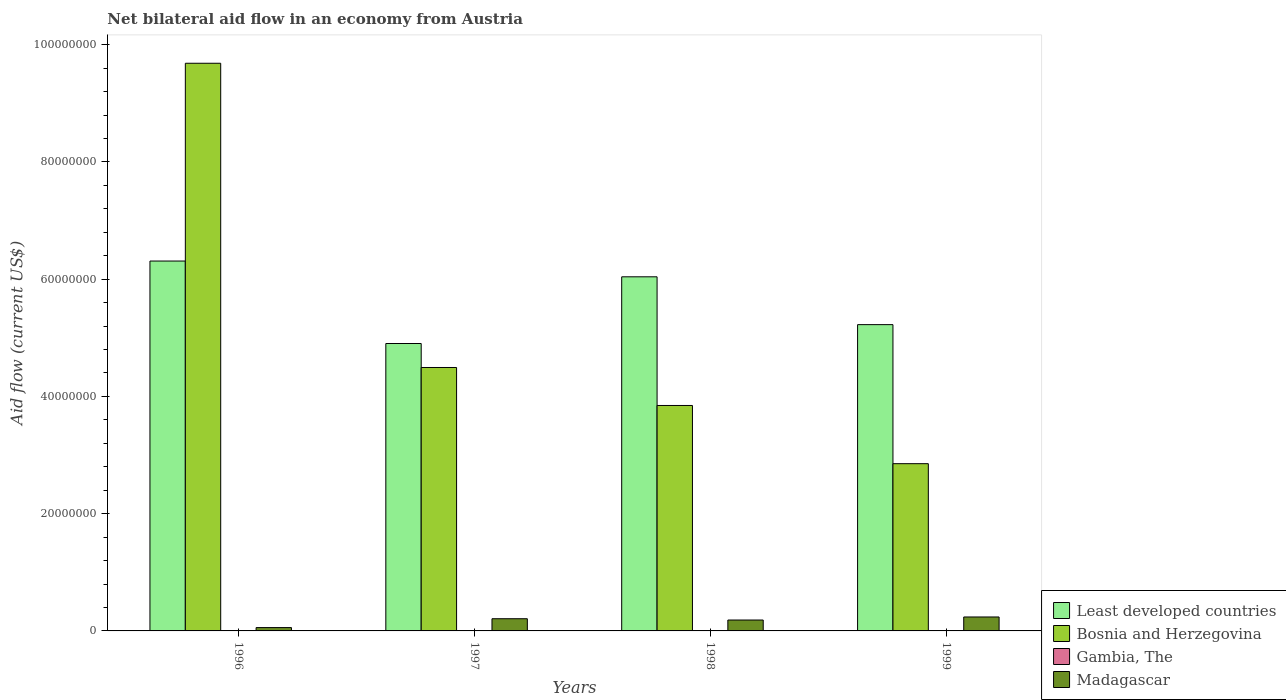Are the number of bars per tick equal to the number of legend labels?
Give a very brief answer. No. Are the number of bars on each tick of the X-axis equal?
Make the answer very short. No. How many bars are there on the 4th tick from the left?
Keep it short and to the point. 4. How many bars are there on the 2nd tick from the right?
Your response must be concise. 4. What is the net bilateral aid flow in Gambia, The in 1999?
Provide a succinct answer. 7.00e+04. Across all years, what is the maximum net bilateral aid flow in Madagascar?
Make the answer very short. 2.38e+06. Across all years, what is the minimum net bilateral aid flow in Madagascar?
Make the answer very short. 5.70e+05. In which year was the net bilateral aid flow in Least developed countries maximum?
Offer a terse response. 1996. What is the total net bilateral aid flow in Least developed countries in the graph?
Make the answer very short. 2.25e+08. What is the difference between the net bilateral aid flow in Gambia, The in 1998 and that in 1999?
Offer a terse response. -6.00e+04. What is the difference between the net bilateral aid flow in Madagascar in 1997 and the net bilateral aid flow in Gambia, The in 1996?
Offer a terse response. 2.05e+06. What is the average net bilateral aid flow in Gambia, The per year?
Give a very brief answer. 2.75e+04. In the year 1998, what is the difference between the net bilateral aid flow in Least developed countries and net bilateral aid flow in Madagascar?
Your answer should be compact. 5.86e+07. What is the ratio of the net bilateral aid flow in Bosnia and Herzegovina in 1997 to that in 1999?
Make the answer very short. 1.58. Is the net bilateral aid flow in Bosnia and Herzegovina in 1996 less than that in 1999?
Your response must be concise. No. What is the difference between the highest and the second highest net bilateral aid flow in Bosnia and Herzegovina?
Offer a terse response. 5.19e+07. What is the difference between the highest and the lowest net bilateral aid flow in Bosnia and Herzegovina?
Your answer should be very brief. 6.83e+07. Are all the bars in the graph horizontal?
Give a very brief answer. No. How many years are there in the graph?
Your answer should be very brief. 4. Are the values on the major ticks of Y-axis written in scientific E-notation?
Give a very brief answer. No. Does the graph contain grids?
Keep it short and to the point. No. Where does the legend appear in the graph?
Offer a terse response. Bottom right. How are the legend labels stacked?
Your response must be concise. Vertical. What is the title of the graph?
Provide a short and direct response. Net bilateral aid flow in an economy from Austria. What is the label or title of the X-axis?
Your answer should be very brief. Years. What is the label or title of the Y-axis?
Give a very brief answer. Aid flow (current US$). What is the Aid flow (current US$) in Least developed countries in 1996?
Make the answer very short. 6.31e+07. What is the Aid flow (current US$) of Bosnia and Herzegovina in 1996?
Provide a short and direct response. 9.68e+07. What is the Aid flow (current US$) of Madagascar in 1996?
Provide a succinct answer. 5.70e+05. What is the Aid flow (current US$) in Least developed countries in 1997?
Provide a short and direct response. 4.90e+07. What is the Aid flow (current US$) in Bosnia and Herzegovina in 1997?
Ensure brevity in your answer.  4.49e+07. What is the Aid flow (current US$) of Gambia, The in 1997?
Offer a terse response. 0. What is the Aid flow (current US$) of Madagascar in 1997?
Your response must be concise. 2.08e+06. What is the Aid flow (current US$) of Least developed countries in 1998?
Provide a succinct answer. 6.04e+07. What is the Aid flow (current US$) in Bosnia and Herzegovina in 1998?
Make the answer very short. 3.85e+07. What is the Aid flow (current US$) in Gambia, The in 1998?
Your response must be concise. 10000. What is the Aid flow (current US$) of Madagascar in 1998?
Offer a very short reply. 1.86e+06. What is the Aid flow (current US$) of Least developed countries in 1999?
Keep it short and to the point. 5.22e+07. What is the Aid flow (current US$) of Bosnia and Herzegovina in 1999?
Your response must be concise. 2.85e+07. What is the Aid flow (current US$) of Madagascar in 1999?
Provide a short and direct response. 2.38e+06. Across all years, what is the maximum Aid flow (current US$) in Least developed countries?
Provide a short and direct response. 6.31e+07. Across all years, what is the maximum Aid flow (current US$) of Bosnia and Herzegovina?
Provide a succinct answer. 9.68e+07. Across all years, what is the maximum Aid flow (current US$) in Gambia, The?
Provide a short and direct response. 7.00e+04. Across all years, what is the maximum Aid flow (current US$) of Madagascar?
Ensure brevity in your answer.  2.38e+06. Across all years, what is the minimum Aid flow (current US$) of Least developed countries?
Give a very brief answer. 4.90e+07. Across all years, what is the minimum Aid flow (current US$) in Bosnia and Herzegovina?
Your response must be concise. 2.85e+07. Across all years, what is the minimum Aid flow (current US$) in Madagascar?
Provide a short and direct response. 5.70e+05. What is the total Aid flow (current US$) of Least developed countries in the graph?
Offer a terse response. 2.25e+08. What is the total Aid flow (current US$) of Bosnia and Herzegovina in the graph?
Provide a succinct answer. 2.09e+08. What is the total Aid flow (current US$) of Madagascar in the graph?
Keep it short and to the point. 6.89e+06. What is the difference between the Aid flow (current US$) of Least developed countries in 1996 and that in 1997?
Provide a succinct answer. 1.41e+07. What is the difference between the Aid flow (current US$) in Bosnia and Herzegovina in 1996 and that in 1997?
Your answer should be compact. 5.19e+07. What is the difference between the Aid flow (current US$) in Madagascar in 1996 and that in 1997?
Your answer should be very brief. -1.51e+06. What is the difference between the Aid flow (current US$) in Least developed countries in 1996 and that in 1998?
Give a very brief answer. 2.69e+06. What is the difference between the Aid flow (current US$) of Bosnia and Herzegovina in 1996 and that in 1998?
Keep it short and to the point. 5.84e+07. What is the difference between the Aid flow (current US$) of Gambia, The in 1996 and that in 1998?
Your answer should be compact. 2.00e+04. What is the difference between the Aid flow (current US$) of Madagascar in 1996 and that in 1998?
Provide a succinct answer. -1.29e+06. What is the difference between the Aid flow (current US$) of Least developed countries in 1996 and that in 1999?
Ensure brevity in your answer.  1.08e+07. What is the difference between the Aid flow (current US$) in Bosnia and Herzegovina in 1996 and that in 1999?
Ensure brevity in your answer.  6.83e+07. What is the difference between the Aid flow (current US$) in Madagascar in 1996 and that in 1999?
Your response must be concise. -1.81e+06. What is the difference between the Aid flow (current US$) of Least developed countries in 1997 and that in 1998?
Provide a short and direct response. -1.14e+07. What is the difference between the Aid flow (current US$) in Bosnia and Herzegovina in 1997 and that in 1998?
Offer a very short reply. 6.48e+06. What is the difference between the Aid flow (current US$) of Madagascar in 1997 and that in 1998?
Give a very brief answer. 2.20e+05. What is the difference between the Aid flow (current US$) of Least developed countries in 1997 and that in 1999?
Make the answer very short. -3.22e+06. What is the difference between the Aid flow (current US$) of Bosnia and Herzegovina in 1997 and that in 1999?
Provide a short and direct response. 1.64e+07. What is the difference between the Aid flow (current US$) of Madagascar in 1997 and that in 1999?
Offer a terse response. -3.00e+05. What is the difference between the Aid flow (current US$) in Least developed countries in 1998 and that in 1999?
Provide a succinct answer. 8.16e+06. What is the difference between the Aid flow (current US$) in Bosnia and Herzegovina in 1998 and that in 1999?
Keep it short and to the point. 9.93e+06. What is the difference between the Aid flow (current US$) in Gambia, The in 1998 and that in 1999?
Your answer should be compact. -6.00e+04. What is the difference between the Aid flow (current US$) of Madagascar in 1998 and that in 1999?
Keep it short and to the point. -5.20e+05. What is the difference between the Aid flow (current US$) in Least developed countries in 1996 and the Aid flow (current US$) in Bosnia and Herzegovina in 1997?
Ensure brevity in your answer.  1.82e+07. What is the difference between the Aid flow (current US$) of Least developed countries in 1996 and the Aid flow (current US$) of Madagascar in 1997?
Your answer should be very brief. 6.10e+07. What is the difference between the Aid flow (current US$) in Bosnia and Herzegovina in 1996 and the Aid flow (current US$) in Madagascar in 1997?
Your answer should be compact. 9.48e+07. What is the difference between the Aid flow (current US$) in Gambia, The in 1996 and the Aid flow (current US$) in Madagascar in 1997?
Give a very brief answer. -2.05e+06. What is the difference between the Aid flow (current US$) in Least developed countries in 1996 and the Aid flow (current US$) in Bosnia and Herzegovina in 1998?
Ensure brevity in your answer.  2.46e+07. What is the difference between the Aid flow (current US$) in Least developed countries in 1996 and the Aid flow (current US$) in Gambia, The in 1998?
Ensure brevity in your answer.  6.31e+07. What is the difference between the Aid flow (current US$) in Least developed countries in 1996 and the Aid flow (current US$) in Madagascar in 1998?
Offer a terse response. 6.12e+07. What is the difference between the Aid flow (current US$) of Bosnia and Herzegovina in 1996 and the Aid flow (current US$) of Gambia, The in 1998?
Your response must be concise. 9.68e+07. What is the difference between the Aid flow (current US$) in Bosnia and Herzegovina in 1996 and the Aid flow (current US$) in Madagascar in 1998?
Make the answer very short. 9.50e+07. What is the difference between the Aid flow (current US$) of Gambia, The in 1996 and the Aid flow (current US$) of Madagascar in 1998?
Keep it short and to the point. -1.83e+06. What is the difference between the Aid flow (current US$) in Least developed countries in 1996 and the Aid flow (current US$) in Bosnia and Herzegovina in 1999?
Keep it short and to the point. 3.46e+07. What is the difference between the Aid flow (current US$) of Least developed countries in 1996 and the Aid flow (current US$) of Gambia, The in 1999?
Keep it short and to the point. 6.30e+07. What is the difference between the Aid flow (current US$) in Least developed countries in 1996 and the Aid flow (current US$) in Madagascar in 1999?
Your answer should be very brief. 6.07e+07. What is the difference between the Aid flow (current US$) of Bosnia and Herzegovina in 1996 and the Aid flow (current US$) of Gambia, The in 1999?
Offer a terse response. 9.68e+07. What is the difference between the Aid flow (current US$) of Bosnia and Herzegovina in 1996 and the Aid flow (current US$) of Madagascar in 1999?
Your answer should be compact. 9.45e+07. What is the difference between the Aid flow (current US$) in Gambia, The in 1996 and the Aid flow (current US$) in Madagascar in 1999?
Ensure brevity in your answer.  -2.35e+06. What is the difference between the Aid flow (current US$) in Least developed countries in 1997 and the Aid flow (current US$) in Bosnia and Herzegovina in 1998?
Your answer should be very brief. 1.06e+07. What is the difference between the Aid flow (current US$) of Least developed countries in 1997 and the Aid flow (current US$) of Gambia, The in 1998?
Give a very brief answer. 4.90e+07. What is the difference between the Aid flow (current US$) of Least developed countries in 1997 and the Aid flow (current US$) of Madagascar in 1998?
Provide a succinct answer. 4.72e+07. What is the difference between the Aid flow (current US$) in Bosnia and Herzegovina in 1997 and the Aid flow (current US$) in Gambia, The in 1998?
Make the answer very short. 4.49e+07. What is the difference between the Aid flow (current US$) in Bosnia and Herzegovina in 1997 and the Aid flow (current US$) in Madagascar in 1998?
Give a very brief answer. 4.31e+07. What is the difference between the Aid flow (current US$) in Least developed countries in 1997 and the Aid flow (current US$) in Bosnia and Herzegovina in 1999?
Ensure brevity in your answer.  2.05e+07. What is the difference between the Aid flow (current US$) of Least developed countries in 1997 and the Aid flow (current US$) of Gambia, The in 1999?
Your answer should be compact. 4.90e+07. What is the difference between the Aid flow (current US$) in Least developed countries in 1997 and the Aid flow (current US$) in Madagascar in 1999?
Keep it short and to the point. 4.66e+07. What is the difference between the Aid flow (current US$) of Bosnia and Herzegovina in 1997 and the Aid flow (current US$) of Gambia, The in 1999?
Provide a succinct answer. 4.49e+07. What is the difference between the Aid flow (current US$) in Bosnia and Herzegovina in 1997 and the Aid flow (current US$) in Madagascar in 1999?
Offer a terse response. 4.26e+07. What is the difference between the Aid flow (current US$) in Least developed countries in 1998 and the Aid flow (current US$) in Bosnia and Herzegovina in 1999?
Provide a short and direct response. 3.19e+07. What is the difference between the Aid flow (current US$) of Least developed countries in 1998 and the Aid flow (current US$) of Gambia, The in 1999?
Your answer should be very brief. 6.03e+07. What is the difference between the Aid flow (current US$) in Least developed countries in 1998 and the Aid flow (current US$) in Madagascar in 1999?
Keep it short and to the point. 5.80e+07. What is the difference between the Aid flow (current US$) in Bosnia and Herzegovina in 1998 and the Aid flow (current US$) in Gambia, The in 1999?
Your answer should be compact. 3.84e+07. What is the difference between the Aid flow (current US$) in Bosnia and Herzegovina in 1998 and the Aid flow (current US$) in Madagascar in 1999?
Your response must be concise. 3.61e+07. What is the difference between the Aid flow (current US$) of Gambia, The in 1998 and the Aid flow (current US$) of Madagascar in 1999?
Offer a terse response. -2.37e+06. What is the average Aid flow (current US$) of Least developed countries per year?
Provide a short and direct response. 5.62e+07. What is the average Aid flow (current US$) in Bosnia and Herzegovina per year?
Your response must be concise. 5.22e+07. What is the average Aid flow (current US$) of Gambia, The per year?
Offer a terse response. 2.75e+04. What is the average Aid flow (current US$) in Madagascar per year?
Offer a terse response. 1.72e+06. In the year 1996, what is the difference between the Aid flow (current US$) in Least developed countries and Aid flow (current US$) in Bosnia and Herzegovina?
Give a very brief answer. -3.37e+07. In the year 1996, what is the difference between the Aid flow (current US$) of Least developed countries and Aid flow (current US$) of Gambia, The?
Your answer should be compact. 6.31e+07. In the year 1996, what is the difference between the Aid flow (current US$) of Least developed countries and Aid flow (current US$) of Madagascar?
Provide a succinct answer. 6.25e+07. In the year 1996, what is the difference between the Aid flow (current US$) of Bosnia and Herzegovina and Aid flow (current US$) of Gambia, The?
Ensure brevity in your answer.  9.68e+07. In the year 1996, what is the difference between the Aid flow (current US$) in Bosnia and Herzegovina and Aid flow (current US$) in Madagascar?
Make the answer very short. 9.63e+07. In the year 1996, what is the difference between the Aid flow (current US$) of Gambia, The and Aid flow (current US$) of Madagascar?
Your answer should be compact. -5.40e+05. In the year 1997, what is the difference between the Aid flow (current US$) in Least developed countries and Aid flow (current US$) in Bosnia and Herzegovina?
Ensure brevity in your answer.  4.09e+06. In the year 1997, what is the difference between the Aid flow (current US$) in Least developed countries and Aid flow (current US$) in Madagascar?
Your response must be concise. 4.70e+07. In the year 1997, what is the difference between the Aid flow (current US$) in Bosnia and Herzegovina and Aid flow (current US$) in Madagascar?
Make the answer very short. 4.29e+07. In the year 1998, what is the difference between the Aid flow (current US$) in Least developed countries and Aid flow (current US$) in Bosnia and Herzegovina?
Provide a short and direct response. 2.20e+07. In the year 1998, what is the difference between the Aid flow (current US$) in Least developed countries and Aid flow (current US$) in Gambia, The?
Your answer should be very brief. 6.04e+07. In the year 1998, what is the difference between the Aid flow (current US$) in Least developed countries and Aid flow (current US$) in Madagascar?
Your response must be concise. 5.86e+07. In the year 1998, what is the difference between the Aid flow (current US$) of Bosnia and Herzegovina and Aid flow (current US$) of Gambia, The?
Your response must be concise. 3.84e+07. In the year 1998, what is the difference between the Aid flow (current US$) in Bosnia and Herzegovina and Aid flow (current US$) in Madagascar?
Your answer should be very brief. 3.66e+07. In the year 1998, what is the difference between the Aid flow (current US$) in Gambia, The and Aid flow (current US$) in Madagascar?
Provide a succinct answer. -1.85e+06. In the year 1999, what is the difference between the Aid flow (current US$) of Least developed countries and Aid flow (current US$) of Bosnia and Herzegovina?
Your answer should be very brief. 2.37e+07. In the year 1999, what is the difference between the Aid flow (current US$) of Least developed countries and Aid flow (current US$) of Gambia, The?
Provide a short and direct response. 5.22e+07. In the year 1999, what is the difference between the Aid flow (current US$) in Least developed countries and Aid flow (current US$) in Madagascar?
Provide a succinct answer. 4.99e+07. In the year 1999, what is the difference between the Aid flow (current US$) in Bosnia and Herzegovina and Aid flow (current US$) in Gambia, The?
Provide a succinct answer. 2.85e+07. In the year 1999, what is the difference between the Aid flow (current US$) in Bosnia and Herzegovina and Aid flow (current US$) in Madagascar?
Your response must be concise. 2.62e+07. In the year 1999, what is the difference between the Aid flow (current US$) of Gambia, The and Aid flow (current US$) of Madagascar?
Offer a very short reply. -2.31e+06. What is the ratio of the Aid flow (current US$) in Least developed countries in 1996 to that in 1997?
Make the answer very short. 1.29. What is the ratio of the Aid flow (current US$) of Bosnia and Herzegovina in 1996 to that in 1997?
Offer a very short reply. 2.15. What is the ratio of the Aid flow (current US$) of Madagascar in 1996 to that in 1997?
Ensure brevity in your answer.  0.27. What is the ratio of the Aid flow (current US$) of Least developed countries in 1996 to that in 1998?
Keep it short and to the point. 1.04. What is the ratio of the Aid flow (current US$) in Bosnia and Herzegovina in 1996 to that in 1998?
Make the answer very short. 2.52. What is the ratio of the Aid flow (current US$) of Gambia, The in 1996 to that in 1998?
Your answer should be compact. 3. What is the ratio of the Aid flow (current US$) of Madagascar in 1996 to that in 1998?
Provide a succinct answer. 0.31. What is the ratio of the Aid flow (current US$) of Least developed countries in 1996 to that in 1999?
Provide a succinct answer. 1.21. What is the ratio of the Aid flow (current US$) of Bosnia and Herzegovina in 1996 to that in 1999?
Offer a terse response. 3.39. What is the ratio of the Aid flow (current US$) in Gambia, The in 1996 to that in 1999?
Provide a short and direct response. 0.43. What is the ratio of the Aid flow (current US$) in Madagascar in 1996 to that in 1999?
Give a very brief answer. 0.24. What is the ratio of the Aid flow (current US$) of Least developed countries in 1997 to that in 1998?
Give a very brief answer. 0.81. What is the ratio of the Aid flow (current US$) in Bosnia and Herzegovina in 1997 to that in 1998?
Provide a succinct answer. 1.17. What is the ratio of the Aid flow (current US$) in Madagascar in 1997 to that in 1998?
Your response must be concise. 1.12. What is the ratio of the Aid flow (current US$) of Least developed countries in 1997 to that in 1999?
Ensure brevity in your answer.  0.94. What is the ratio of the Aid flow (current US$) in Bosnia and Herzegovina in 1997 to that in 1999?
Provide a succinct answer. 1.58. What is the ratio of the Aid flow (current US$) of Madagascar in 1997 to that in 1999?
Keep it short and to the point. 0.87. What is the ratio of the Aid flow (current US$) of Least developed countries in 1998 to that in 1999?
Your response must be concise. 1.16. What is the ratio of the Aid flow (current US$) of Bosnia and Herzegovina in 1998 to that in 1999?
Give a very brief answer. 1.35. What is the ratio of the Aid flow (current US$) in Gambia, The in 1998 to that in 1999?
Give a very brief answer. 0.14. What is the ratio of the Aid flow (current US$) of Madagascar in 1998 to that in 1999?
Make the answer very short. 0.78. What is the difference between the highest and the second highest Aid flow (current US$) of Least developed countries?
Ensure brevity in your answer.  2.69e+06. What is the difference between the highest and the second highest Aid flow (current US$) of Bosnia and Herzegovina?
Give a very brief answer. 5.19e+07. What is the difference between the highest and the second highest Aid flow (current US$) in Madagascar?
Give a very brief answer. 3.00e+05. What is the difference between the highest and the lowest Aid flow (current US$) in Least developed countries?
Ensure brevity in your answer.  1.41e+07. What is the difference between the highest and the lowest Aid flow (current US$) of Bosnia and Herzegovina?
Provide a succinct answer. 6.83e+07. What is the difference between the highest and the lowest Aid flow (current US$) of Gambia, The?
Provide a short and direct response. 7.00e+04. What is the difference between the highest and the lowest Aid flow (current US$) of Madagascar?
Keep it short and to the point. 1.81e+06. 